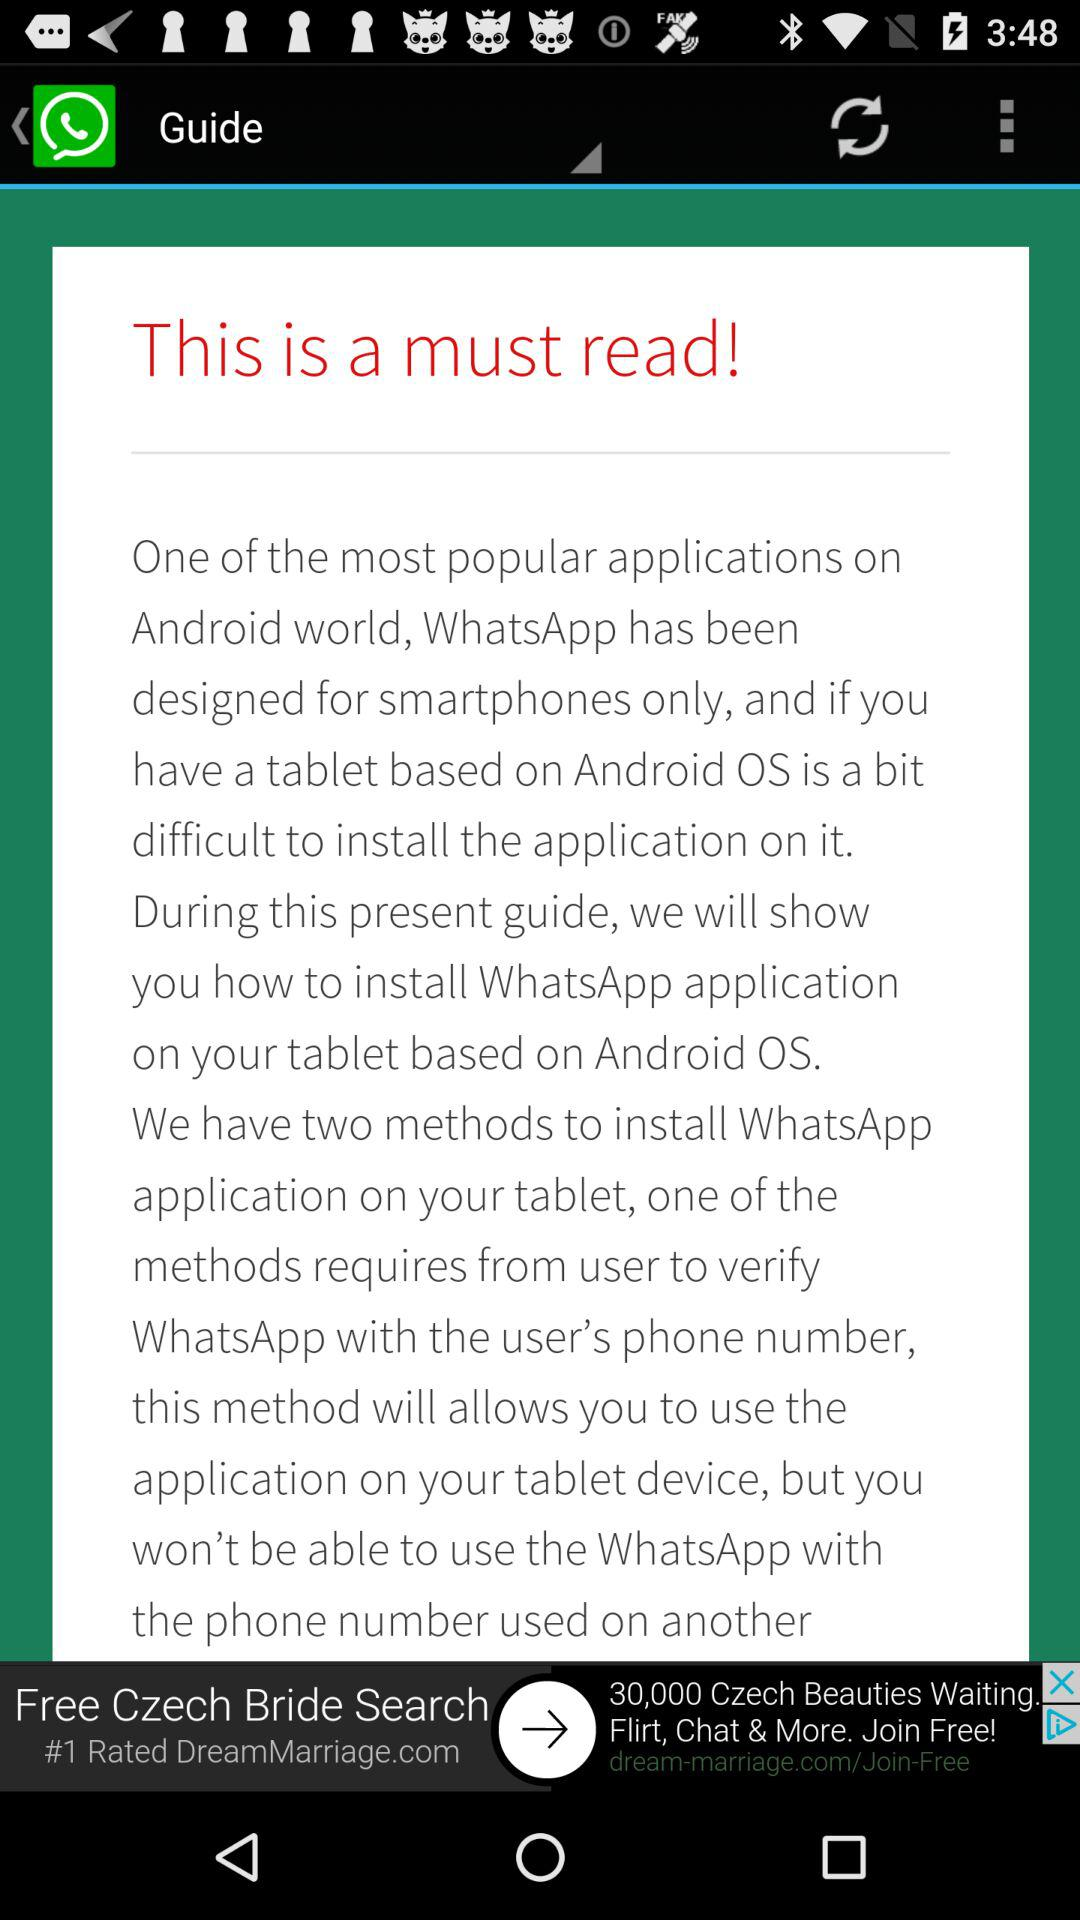For what types of phones is WhatsApp designed? WhatsApp is designed for smartphones only. 